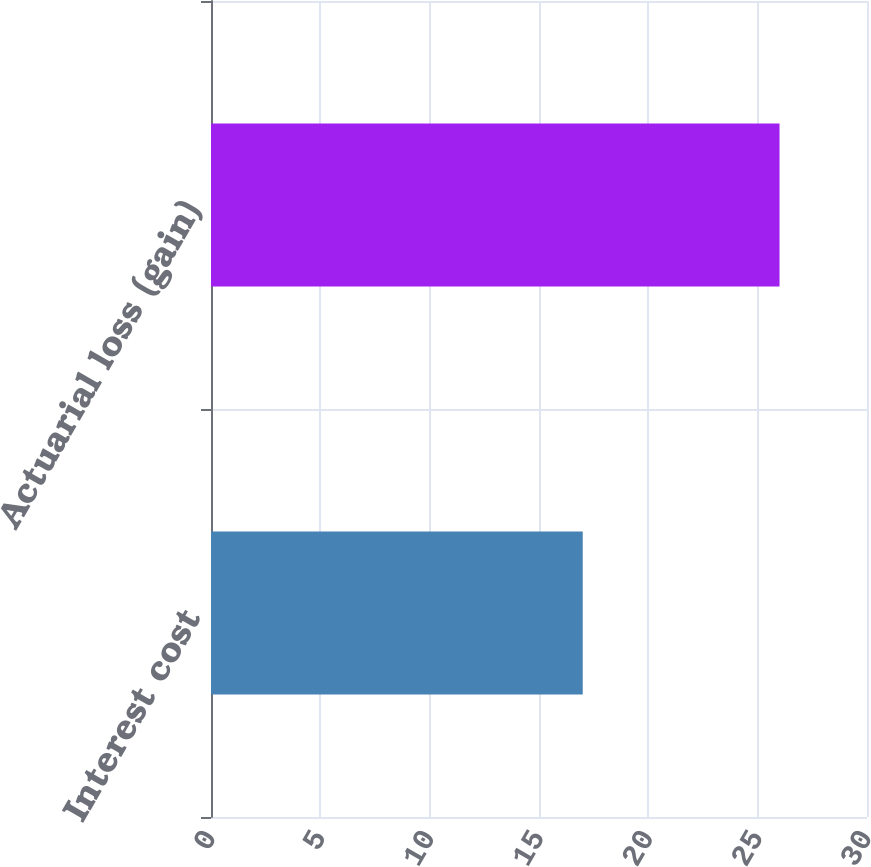Convert chart to OTSL. <chart><loc_0><loc_0><loc_500><loc_500><bar_chart><fcel>Interest cost<fcel>Actuarial loss (gain)<nl><fcel>17<fcel>26<nl></chart> 